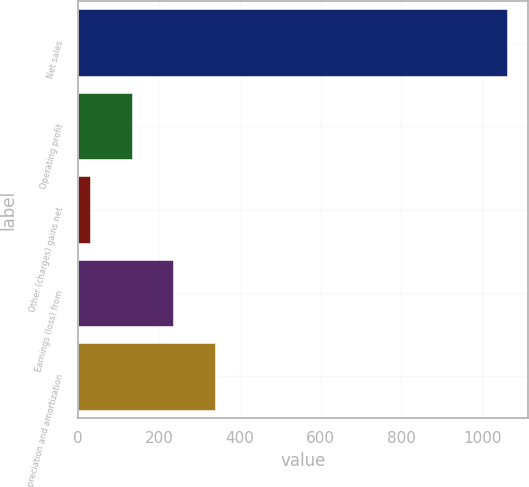Convert chart to OTSL. <chart><loc_0><loc_0><loc_500><loc_500><bar_chart><fcel>Net sales<fcel>Operating profit<fcel>Other (charges) gains net<fcel>Earnings (loss) from<fcel>Depreciation and amortization<nl><fcel>1061<fcel>132.2<fcel>29<fcel>235.4<fcel>338.6<nl></chart> 